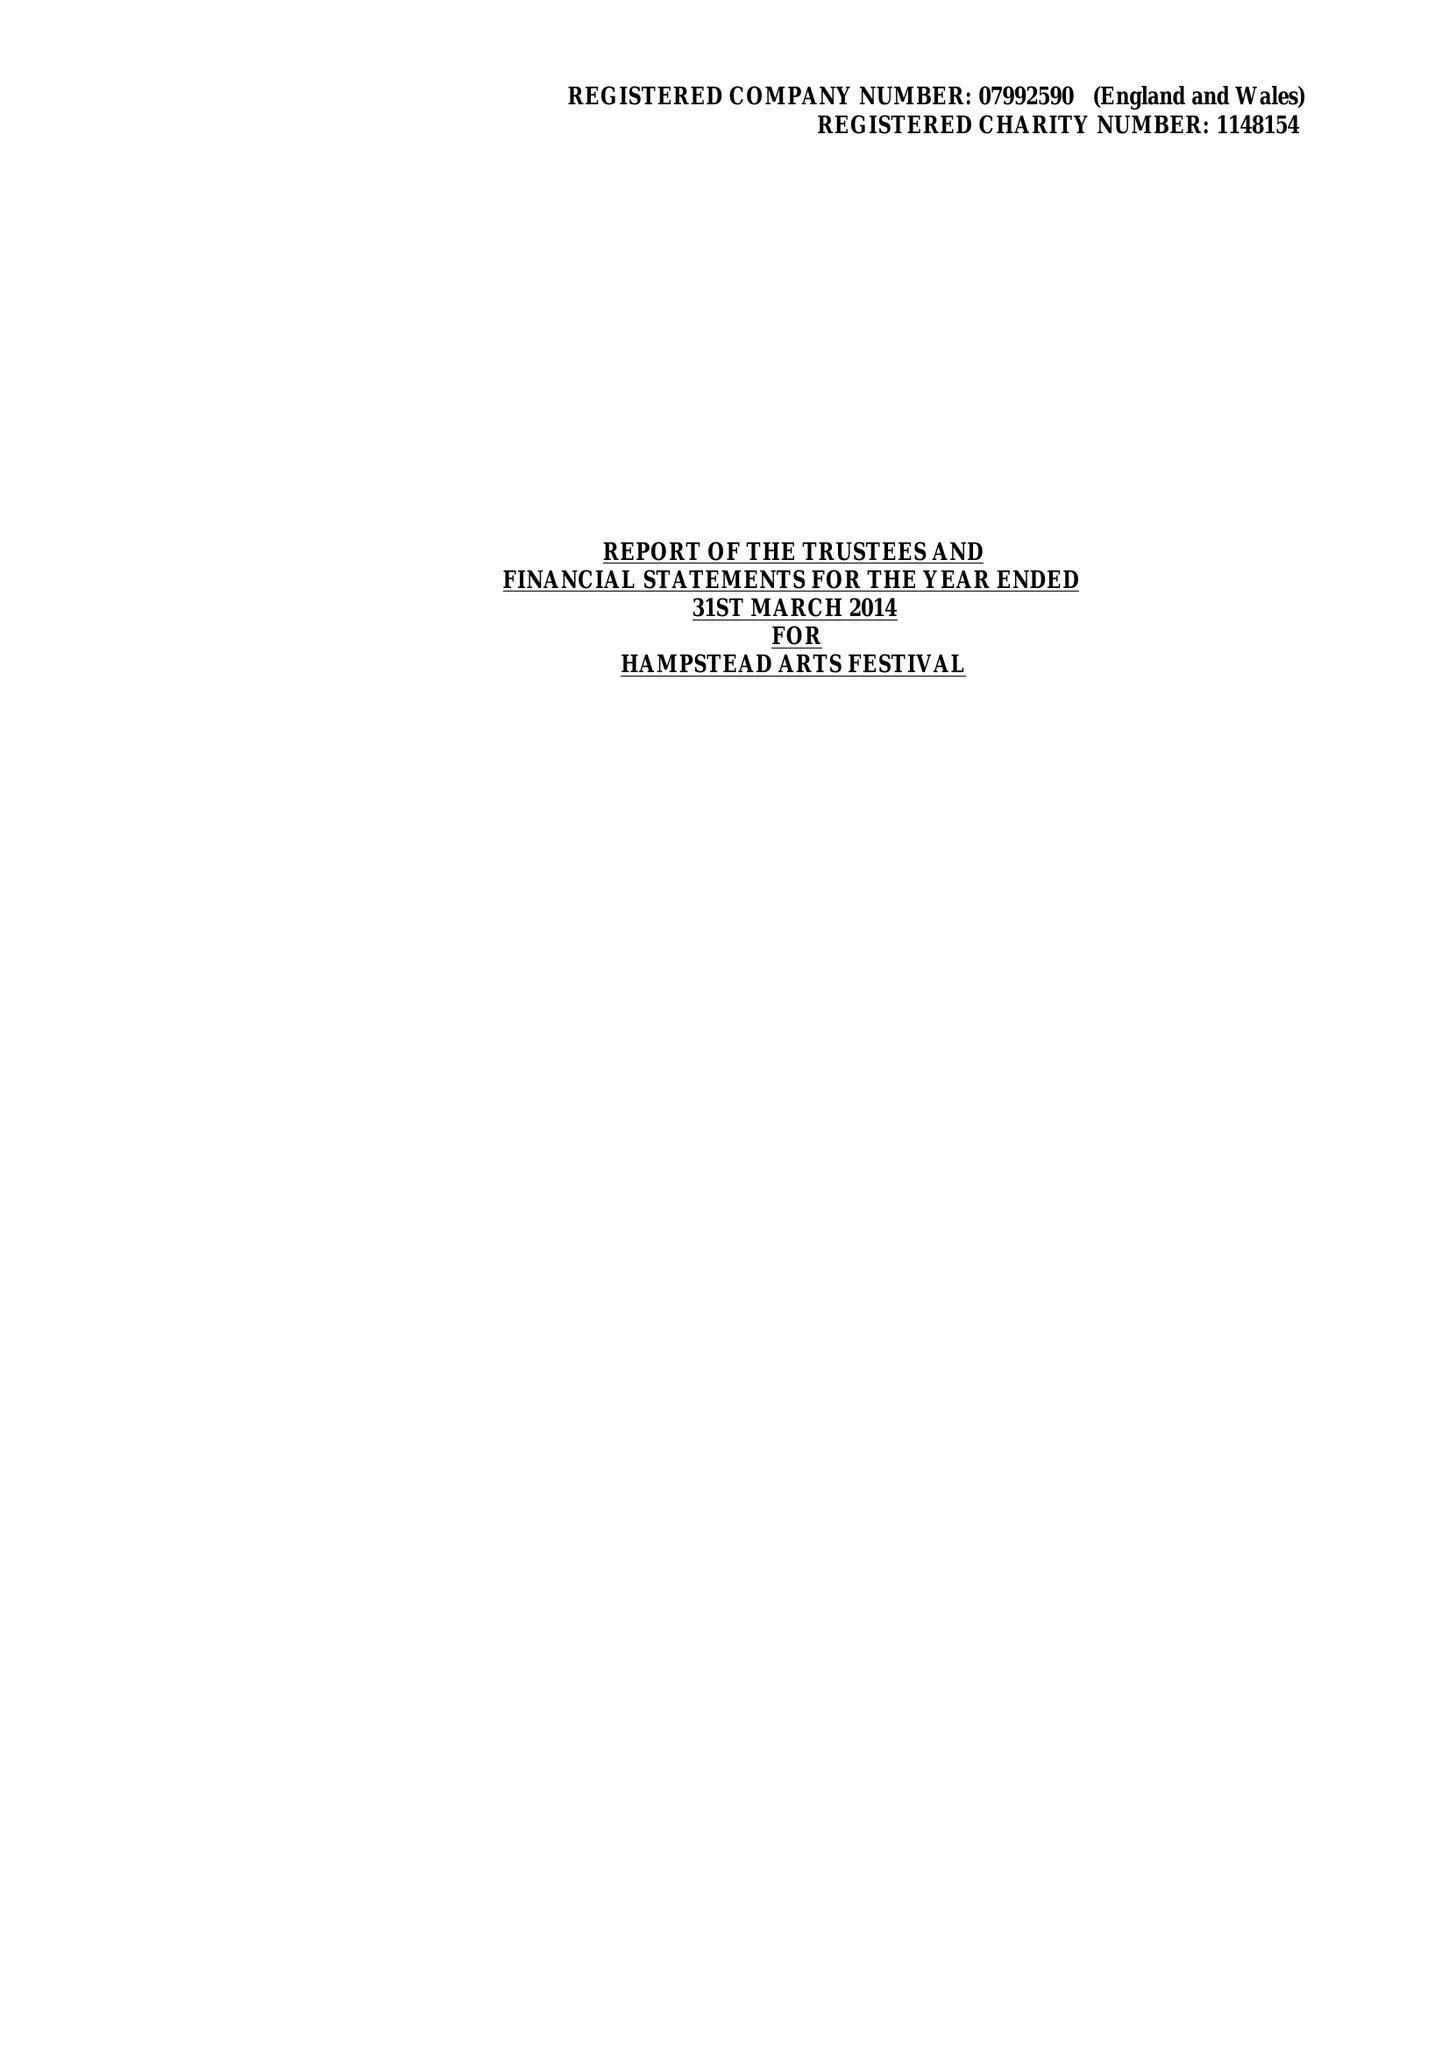What is the value for the income_annually_in_british_pounds?
Answer the question using a single word or phrase. 44407.00 